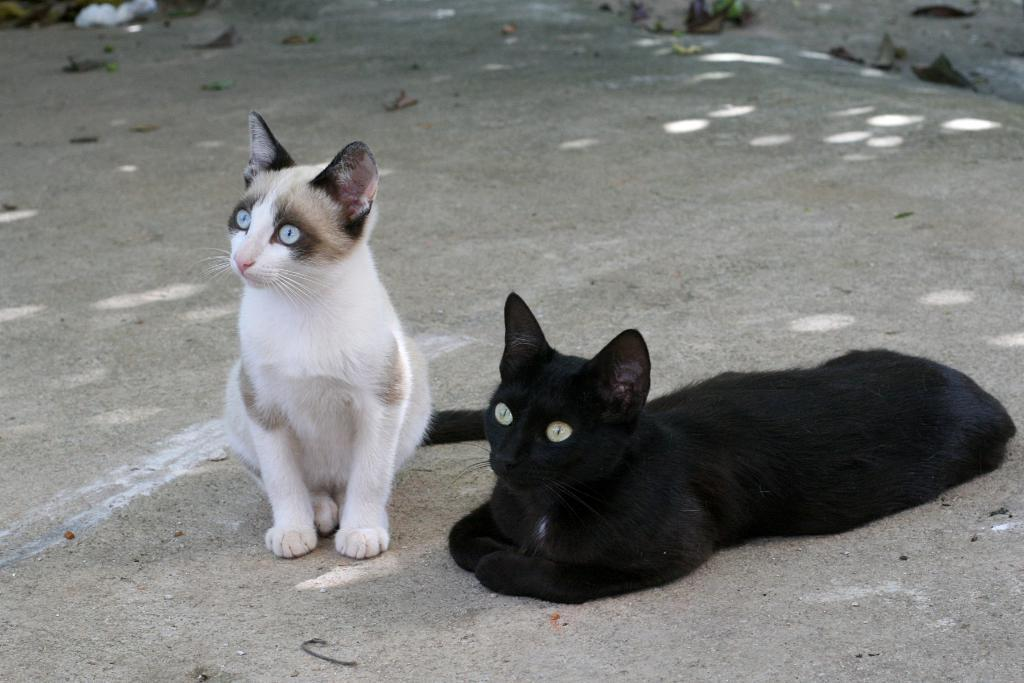What type of animals can be seen in the image? There are cats in the image. What else can be seen on the ground in the image? There are objects on the ground in the image. Are there any bears attacking the cats in the image? There are no bears present in the image, and therefore no such attack can be observed. 